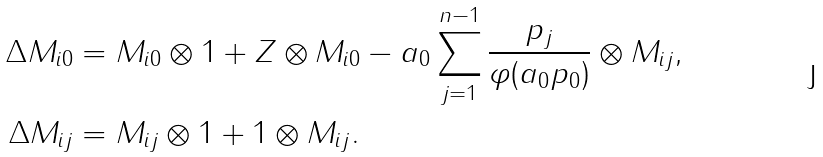<formula> <loc_0><loc_0><loc_500><loc_500>\Delta M _ { i 0 } & = M _ { i 0 } \otimes 1 + Z \otimes M _ { i 0 } - a _ { 0 } \sum _ { j = 1 } ^ { n - 1 } \frac { p _ { j } } { \varphi ( a _ { 0 } p _ { 0 } ) } \otimes M _ { i j } , \\ \Delta M _ { i j } & = M _ { i j } \otimes 1 + 1 \otimes M _ { i j } .</formula> 